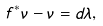Convert formula to latex. <formula><loc_0><loc_0><loc_500><loc_500>f ^ { * } { \nu } - \nu = d \lambda ,</formula> 